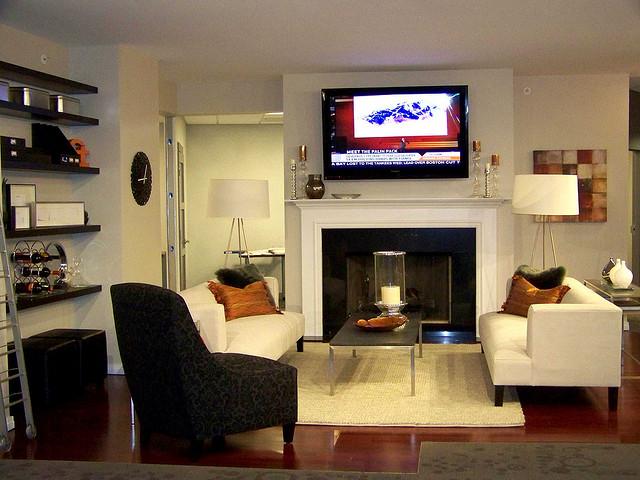What is sitting on the rug?
Concise answer only. Table. How many pillows are pictured?
Be succinct. 4. What geometric shapes make up the artwork on the right side in the background?
Write a very short answer. Squares. What type of room is this?
Give a very brief answer. Living room. Is the table sturdy?
Give a very brief answer. Yes. What type of show is on the TV screen?
Write a very short answer. News. Does this photo reflect the decorating style of the 1980's?
Quick response, please. No. What are they watching on the television?
Be succinct. News. What is on the shelves?
Write a very short answer. Tins. Is there a Toy Story character on the wall?
Give a very brief answer. No. 